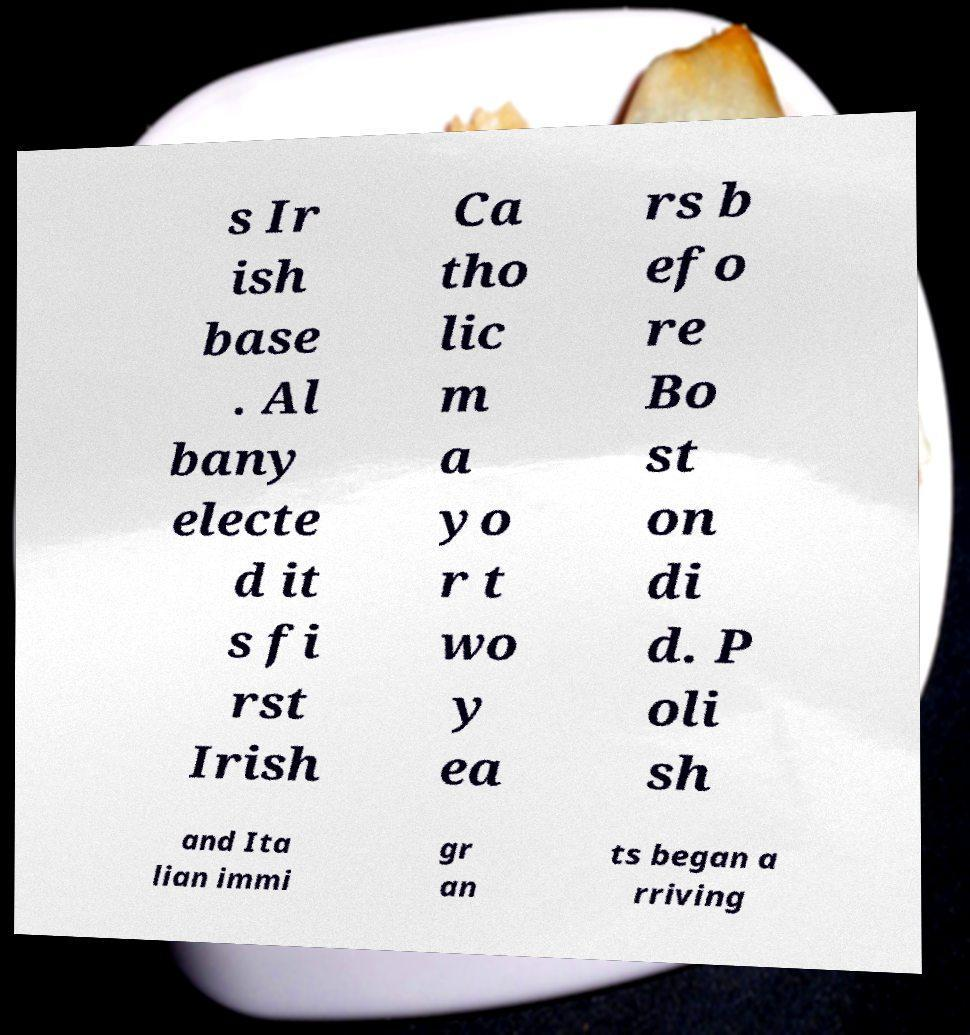Please identify and transcribe the text found in this image. s Ir ish base . Al bany electe d it s fi rst Irish Ca tho lic m a yo r t wo y ea rs b efo re Bo st on di d. P oli sh and Ita lian immi gr an ts began a rriving 